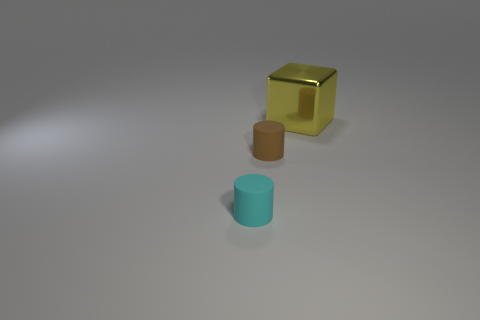Add 1 small brown things. How many objects exist? 4 Subtract 2 cylinders. How many cylinders are left? 0 Subtract all brown cylinders. How many cylinders are left? 1 Subtract 0 green cylinders. How many objects are left? 3 Subtract all cylinders. How many objects are left? 1 Subtract all cyan cylinders. Subtract all red blocks. How many cylinders are left? 1 Subtract all small brown matte cylinders. Subtract all small red rubber objects. How many objects are left? 2 Add 1 tiny cyan things. How many tiny cyan things are left? 2 Add 2 cyan matte cylinders. How many cyan matte cylinders exist? 3 